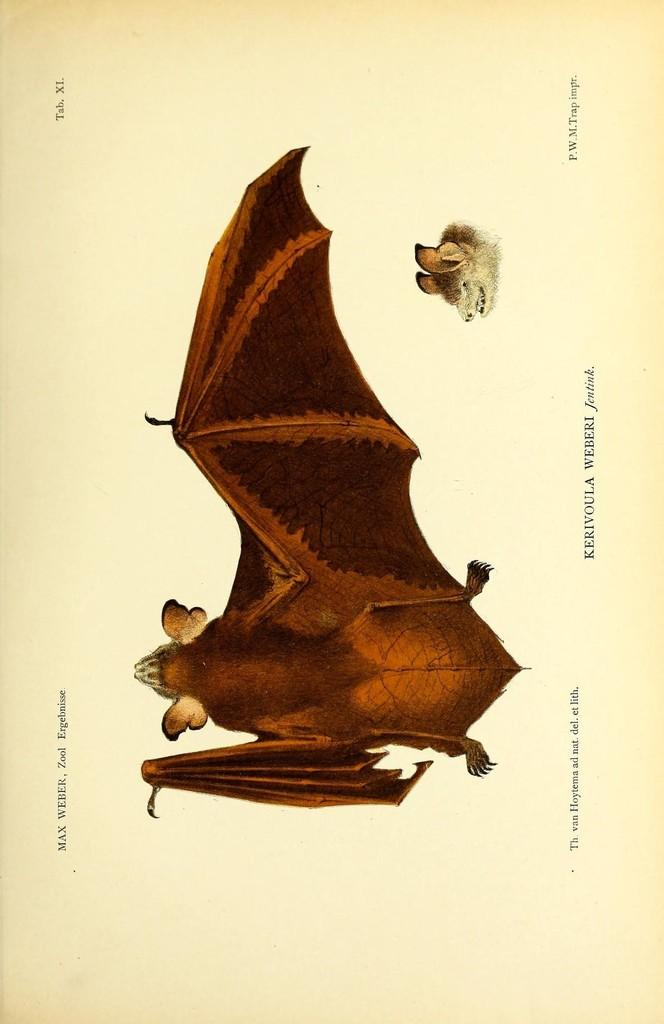What is depicted in the drawing in the image? There is a drawing of an animal in the image. What else can be seen below the drawing? There is a face below the drawing. Are there any words or phrases written in the image? Some matter is written in the image. What type of dolls are being discussed in the image? There is no mention of dolls or any discussion in the image. 